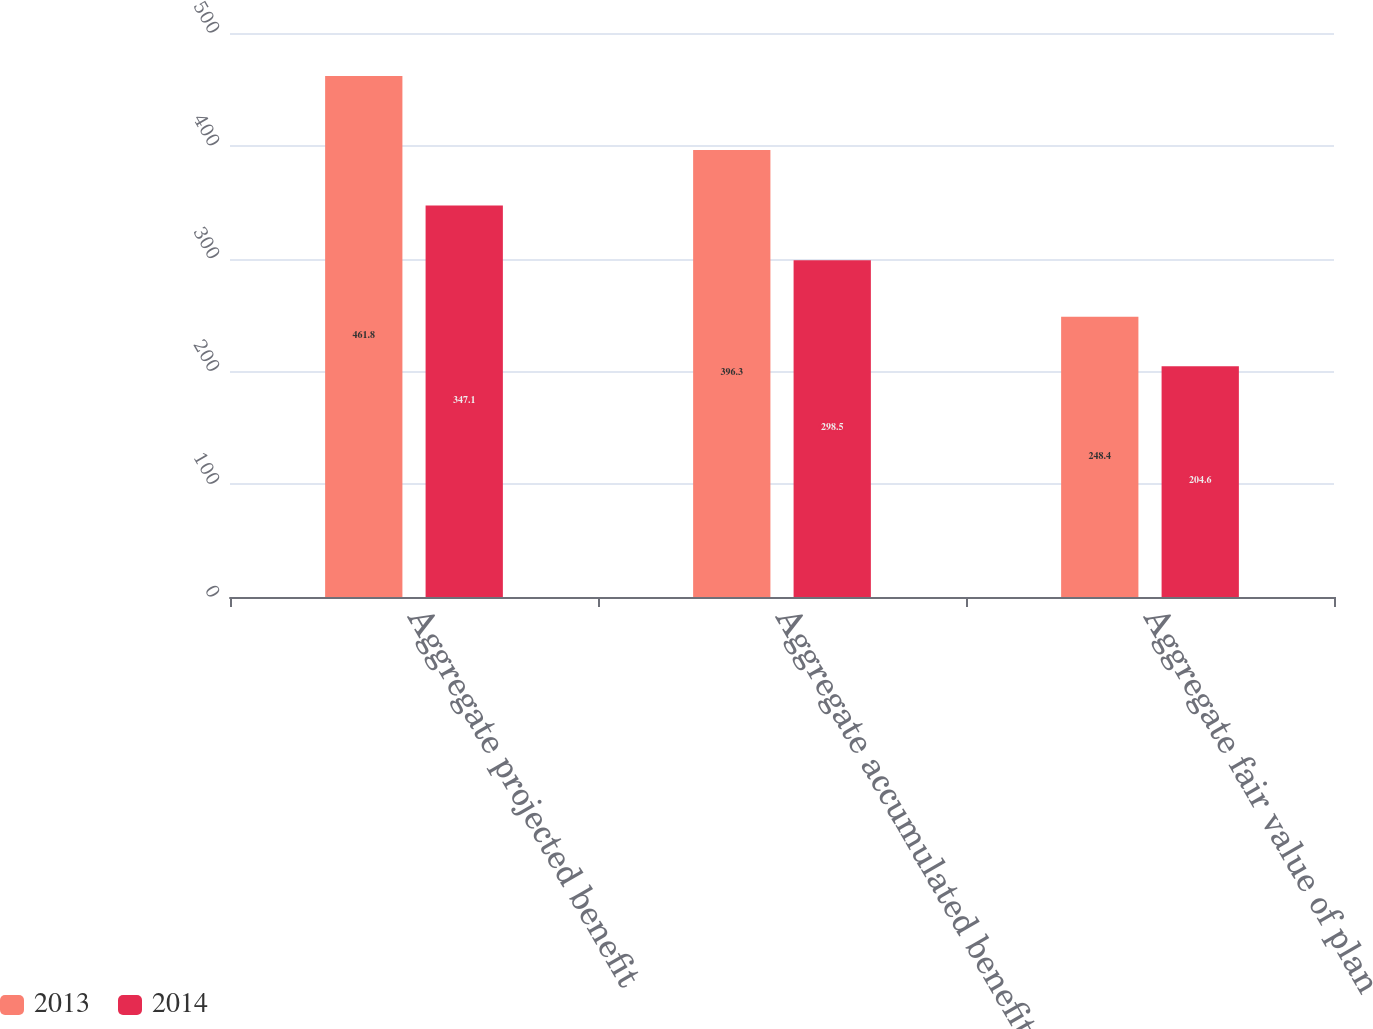Convert chart to OTSL. <chart><loc_0><loc_0><loc_500><loc_500><stacked_bar_chart><ecel><fcel>Aggregate projected benefit<fcel>Aggregate accumulated benefit<fcel>Aggregate fair value of plan<nl><fcel>2013<fcel>461.8<fcel>396.3<fcel>248.4<nl><fcel>2014<fcel>347.1<fcel>298.5<fcel>204.6<nl></chart> 